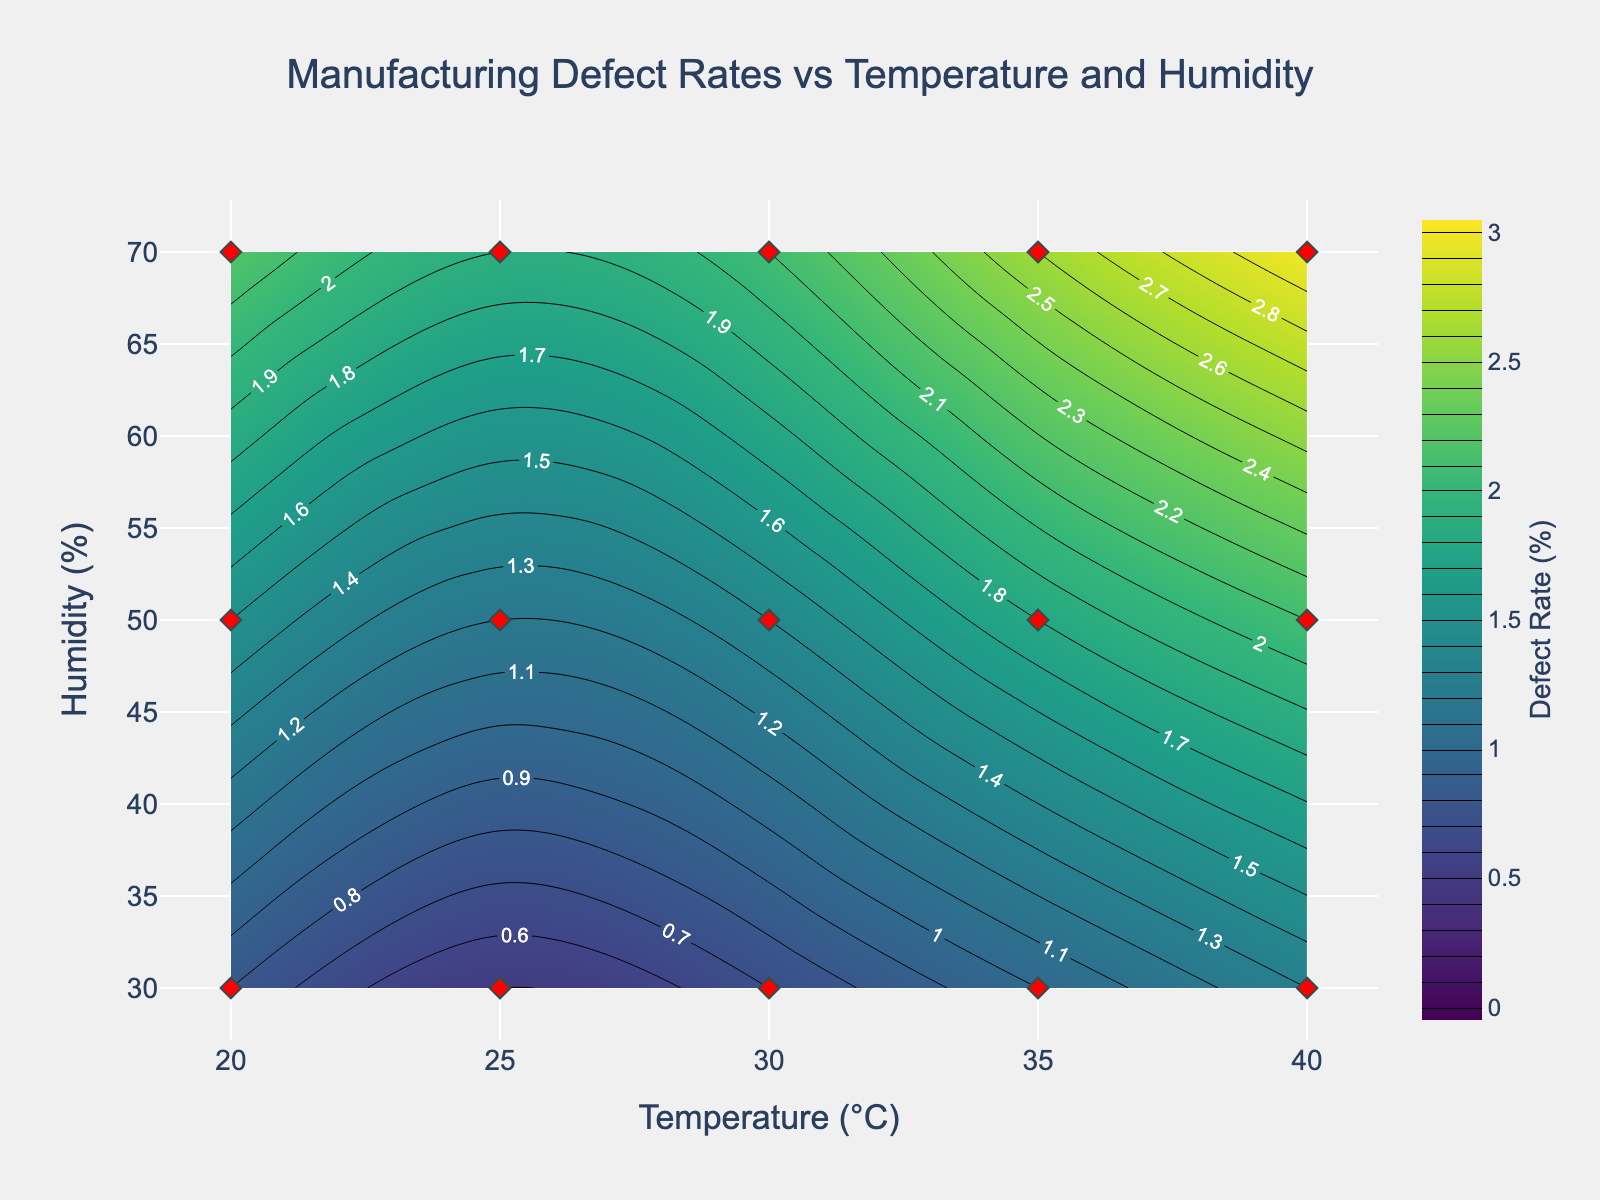What colors are used in the contour plot to represent different defect rates? The contour plot uses a colorscale called 'Viridis,' which ranges from dark purple (representing lower defect rates) to yellow (representing higher defect rates). This gradation helps differentiate between various defect rates visually.
Answer: Dark purple to yellow What is the title of the figure? The title of the figure is shown at the top and reads 'Manufacturing Defect Rates vs Temperature and Humidity'.
Answer: Manufacturing Defect Rates vs Temperature and Humidity How many unique data points are shown in the scatter plot? There are 15 unique data points in the scatter plot, represented by red diamond markers at different temperature and humidity levels.
Answer: 15 What temperature and humidity combination results in approximately a 2.6% defect rate? According to the labelled contour lines, a 2.6% defect rate occurs at a temperature of 35°C and a humidity of 70%.
Answer: 35°C and 70% At which temperature and humidity level do we see the lowest defect rate, and what is that rate? The lowest defect rate is approximately 0.5% and is observed at a temperature of 25°C and humidity of 30%.
Answer: 25°C and 30%, 0.5% Between 25°C and 30°C, which humidity level has the higher defect rate at 30% and 50% humidity? By examining the contour plot, 50% humidity level has a higher defect rate compared to 30% humidity at both 25°C and 30°C temperatures.
Answer: 50% humidity What is the trend of defect rate as humidity increases from 30% to 70% at a constant temperature of 40°C? As humidity increases, the defect rate also increases. For instance, at 40°C, defect rates rise from around 1.3% at 30% humidity to 3.0% at 70% humidity, showing a positive correlation between humidity and defect rate.
Answer: Increases What's the range of temperatures covered in the contour plot? The temperatures in the plot range from 20°C to 40°C, as indicated on the contour plot's x-axis.
Answer: 20°C to 40°C How does a change in temperature from 30°C to 35°C affect defect rates at 50% humidity? The contour plot shows that defect rates increase when the temperature rises from 30°C to 35°C at 50% humidity, from about 1.4% to 1.8%.
Answer: Increases from 1.4% to 1.8% What humidity level has the lowest defect rate at a temperature of 30°C? The 30% humidity level has the lowest defect rate at a temperature of 30°C.
Answer: 30% 